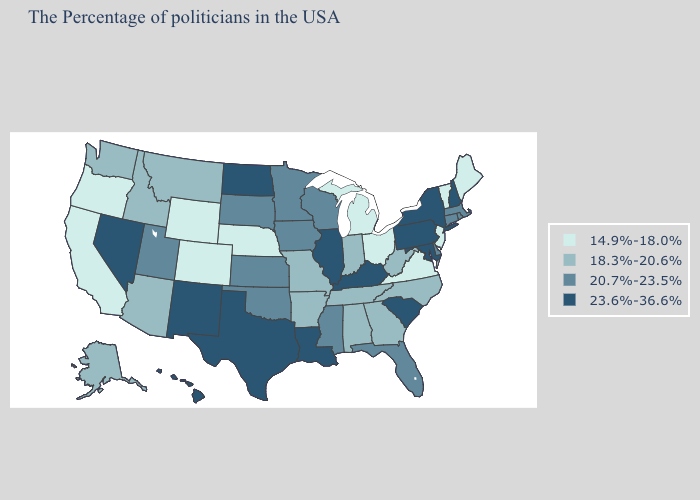Does Montana have the highest value in the West?
Quick response, please. No. Name the states that have a value in the range 18.3%-20.6%?
Concise answer only. North Carolina, West Virginia, Georgia, Indiana, Alabama, Tennessee, Missouri, Arkansas, Montana, Arizona, Idaho, Washington, Alaska. Name the states that have a value in the range 23.6%-36.6%?
Short answer required. New Hampshire, New York, Maryland, Pennsylvania, South Carolina, Kentucky, Illinois, Louisiana, Texas, North Dakota, New Mexico, Nevada, Hawaii. What is the value of Wyoming?
Keep it brief. 14.9%-18.0%. What is the value of Wisconsin?
Concise answer only. 20.7%-23.5%. Does Oregon have the highest value in the West?
Quick response, please. No. Name the states that have a value in the range 14.9%-18.0%?
Give a very brief answer. Maine, Vermont, New Jersey, Virginia, Ohio, Michigan, Nebraska, Wyoming, Colorado, California, Oregon. Name the states that have a value in the range 20.7%-23.5%?
Write a very short answer. Massachusetts, Rhode Island, Connecticut, Delaware, Florida, Wisconsin, Mississippi, Minnesota, Iowa, Kansas, Oklahoma, South Dakota, Utah. Among the states that border North Dakota , does Minnesota have the lowest value?
Short answer required. No. Does Minnesota have the lowest value in the USA?
Write a very short answer. No. Among the states that border Colorado , does New Mexico have the highest value?
Keep it brief. Yes. Among the states that border Idaho , which have the highest value?
Answer briefly. Nevada. Does Maryland have a lower value than Ohio?
Keep it brief. No. Does California have the lowest value in the USA?
Give a very brief answer. Yes. Name the states that have a value in the range 14.9%-18.0%?
Give a very brief answer. Maine, Vermont, New Jersey, Virginia, Ohio, Michigan, Nebraska, Wyoming, Colorado, California, Oregon. 